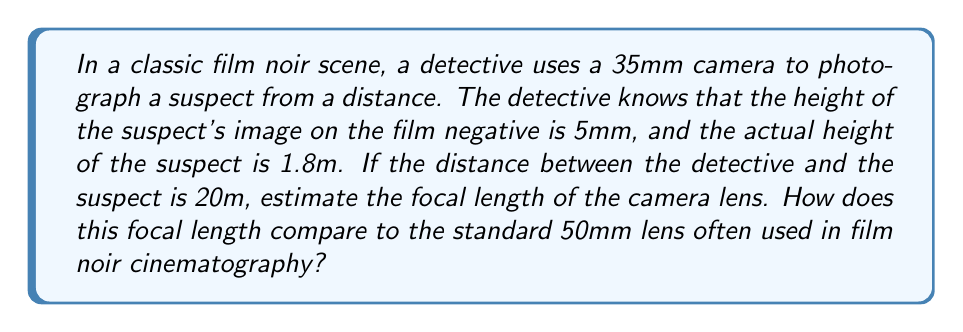Teach me how to tackle this problem. Let's approach this problem step-by-step using similar triangles:

1) We can form two similar triangles: one from the object to the lens, and another from the lens to the image on the film.

2) Let $f$ be the focal length we're trying to find. We know:
   - Image height on film: $h' = 5\text{ mm}$
   - Actual height of suspect: $h = 1.8\text{ m} = 1800\text{ mm}$
   - Distance to suspect: $d = 20\text{ m} = 20000\text{ mm}$

3) Using the principle of similar triangles:

   $$\frac{h'}{f} = \frac{h}{d}$$

4) Substituting our known values:

   $$\frac{5}{f} = \frac{1800}{20000}$$

5) Cross-multiplying:

   $$5 \cdot 20000 = f \cdot 1800$$

6) Solving for $f$:

   $$f = \frac{5 \cdot 20000}{1800} \approx 55.56\text{ mm}$$

7) Comparing to the standard 50mm lens:
   The estimated focal length (55.56mm) is quite close to the standard 50mm lens, which explains why 50mm lenses were popular in film noir. They provide a perspective similar to the human eye, creating a realistic and immersive atmosphere characteristic of the genre.
Answer: 55.56mm, slightly longer than the standard 50mm lens 